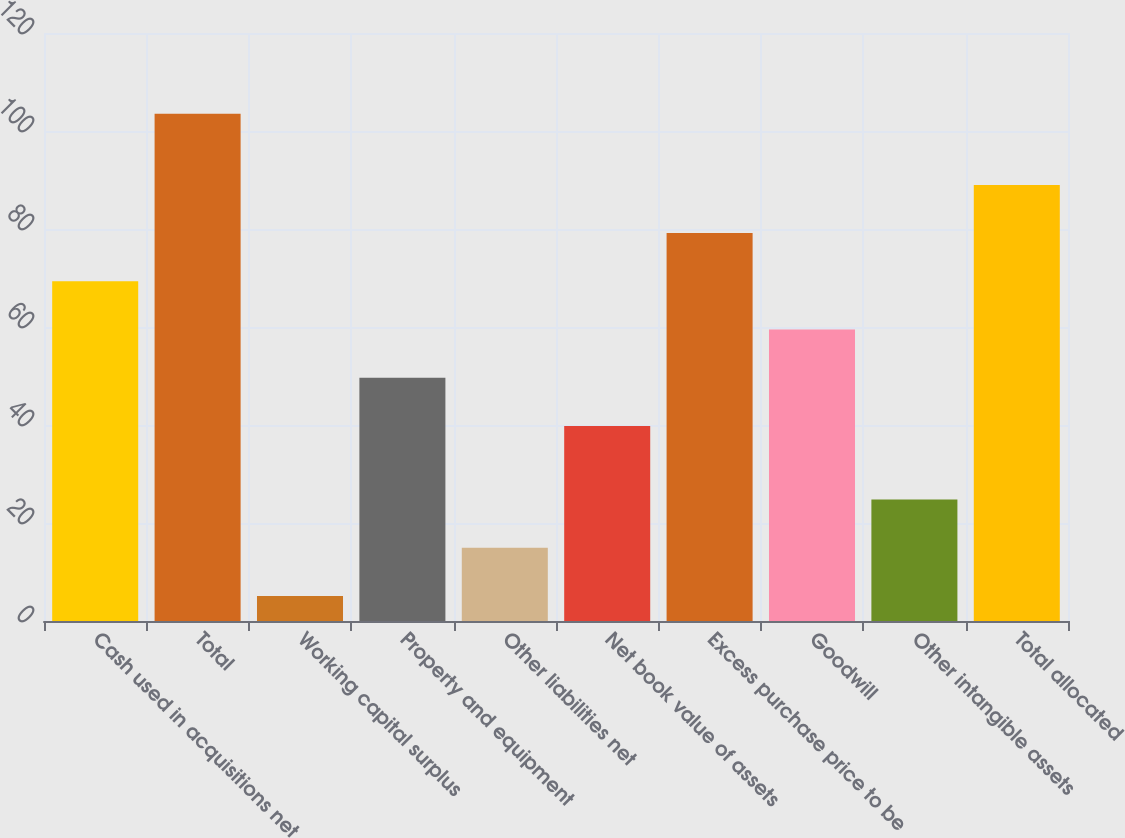<chart> <loc_0><loc_0><loc_500><loc_500><bar_chart><fcel>Cash used in acquisitions net<fcel>Total<fcel>Working capital surplus<fcel>Property and equipment<fcel>Other liabilities net<fcel>Net book value of assets<fcel>Excess purchase price to be<fcel>Goodwill<fcel>Other intangible assets<fcel>Total allocated<nl><fcel>69.32<fcel>103.5<fcel>5.1<fcel>49.64<fcel>14.94<fcel>39.8<fcel>79.16<fcel>59.48<fcel>24.78<fcel>89<nl></chart> 